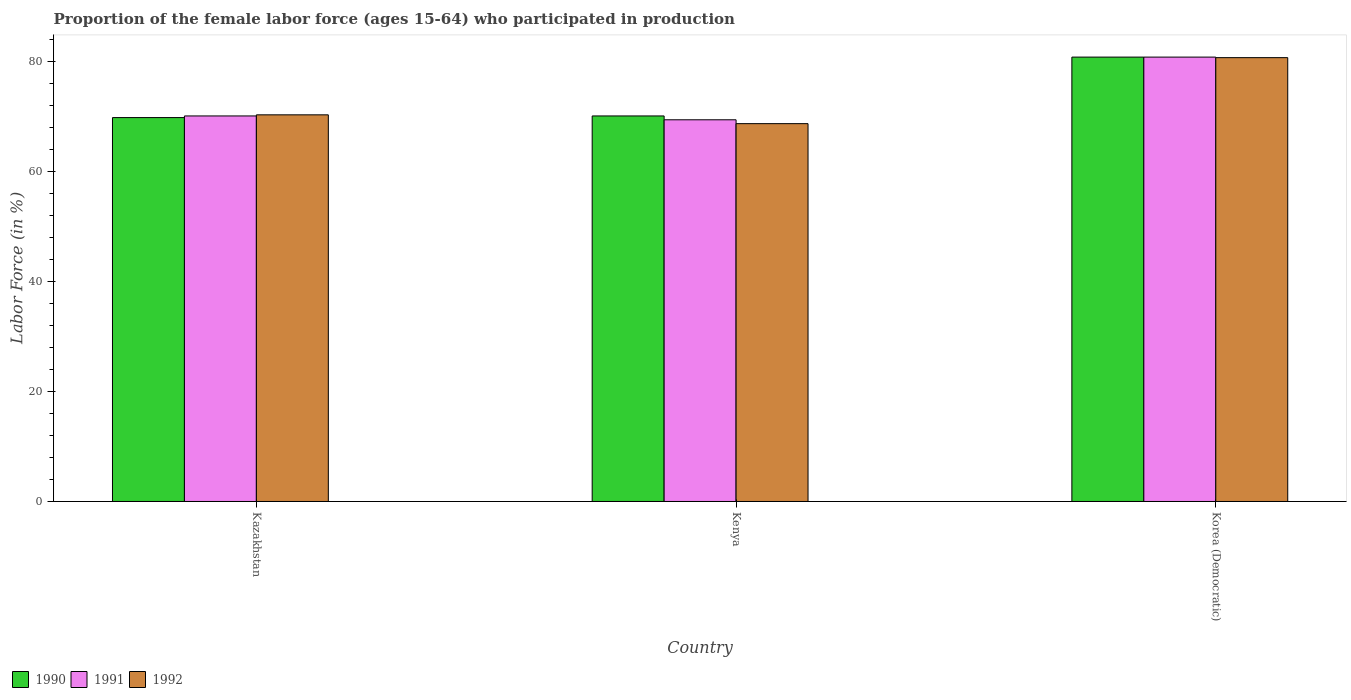Are the number of bars on each tick of the X-axis equal?
Your answer should be compact. Yes. How many bars are there on the 2nd tick from the right?
Your answer should be compact. 3. What is the label of the 3rd group of bars from the left?
Give a very brief answer. Korea (Democratic). In how many cases, is the number of bars for a given country not equal to the number of legend labels?
Ensure brevity in your answer.  0. What is the proportion of the female labor force who participated in production in 1991 in Kenya?
Offer a terse response. 69.4. Across all countries, what is the maximum proportion of the female labor force who participated in production in 1991?
Offer a terse response. 80.8. Across all countries, what is the minimum proportion of the female labor force who participated in production in 1990?
Your answer should be compact. 69.8. In which country was the proportion of the female labor force who participated in production in 1992 maximum?
Your answer should be very brief. Korea (Democratic). In which country was the proportion of the female labor force who participated in production in 1990 minimum?
Make the answer very short. Kazakhstan. What is the total proportion of the female labor force who participated in production in 1991 in the graph?
Your answer should be very brief. 220.3. What is the difference between the proportion of the female labor force who participated in production in 1991 in Kazakhstan and that in Korea (Democratic)?
Keep it short and to the point. -10.7. What is the difference between the proportion of the female labor force who participated in production in 1992 in Korea (Democratic) and the proportion of the female labor force who participated in production in 1990 in Kazakhstan?
Make the answer very short. 10.9. What is the average proportion of the female labor force who participated in production in 1990 per country?
Provide a succinct answer. 73.57. What is the difference between the proportion of the female labor force who participated in production of/in 1992 and proportion of the female labor force who participated in production of/in 1991 in Korea (Democratic)?
Your response must be concise. -0.1. What is the ratio of the proportion of the female labor force who participated in production in 1991 in Kazakhstan to that in Korea (Democratic)?
Provide a short and direct response. 0.87. What is the difference between the highest and the second highest proportion of the female labor force who participated in production in 1991?
Give a very brief answer. 11.4. In how many countries, is the proportion of the female labor force who participated in production in 1990 greater than the average proportion of the female labor force who participated in production in 1990 taken over all countries?
Your answer should be compact. 1. What does the 2nd bar from the right in Korea (Democratic) represents?
Your response must be concise. 1991. Is it the case that in every country, the sum of the proportion of the female labor force who participated in production in 1992 and proportion of the female labor force who participated in production in 1990 is greater than the proportion of the female labor force who participated in production in 1991?
Offer a very short reply. Yes. Are all the bars in the graph horizontal?
Ensure brevity in your answer.  No. How many legend labels are there?
Give a very brief answer. 3. How are the legend labels stacked?
Ensure brevity in your answer.  Horizontal. What is the title of the graph?
Your answer should be very brief. Proportion of the female labor force (ages 15-64) who participated in production. Does "1968" appear as one of the legend labels in the graph?
Offer a very short reply. No. What is the Labor Force (in %) in 1990 in Kazakhstan?
Provide a succinct answer. 69.8. What is the Labor Force (in %) of 1991 in Kazakhstan?
Your answer should be compact. 70.1. What is the Labor Force (in %) in 1992 in Kazakhstan?
Your response must be concise. 70.3. What is the Labor Force (in %) in 1990 in Kenya?
Provide a succinct answer. 70.1. What is the Labor Force (in %) of 1991 in Kenya?
Your answer should be compact. 69.4. What is the Labor Force (in %) of 1992 in Kenya?
Provide a succinct answer. 68.7. What is the Labor Force (in %) in 1990 in Korea (Democratic)?
Offer a very short reply. 80.8. What is the Labor Force (in %) of 1991 in Korea (Democratic)?
Your response must be concise. 80.8. What is the Labor Force (in %) of 1992 in Korea (Democratic)?
Ensure brevity in your answer.  80.7. Across all countries, what is the maximum Labor Force (in %) in 1990?
Give a very brief answer. 80.8. Across all countries, what is the maximum Labor Force (in %) of 1991?
Your response must be concise. 80.8. Across all countries, what is the maximum Labor Force (in %) in 1992?
Keep it short and to the point. 80.7. Across all countries, what is the minimum Labor Force (in %) in 1990?
Give a very brief answer. 69.8. Across all countries, what is the minimum Labor Force (in %) of 1991?
Your answer should be very brief. 69.4. Across all countries, what is the minimum Labor Force (in %) in 1992?
Your answer should be very brief. 68.7. What is the total Labor Force (in %) in 1990 in the graph?
Ensure brevity in your answer.  220.7. What is the total Labor Force (in %) in 1991 in the graph?
Provide a succinct answer. 220.3. What is the total Labor Force (in %) of 1992 in the graph?
Provide a short and direct response. 219.7. What is the difference between the Labor Force (in %) of 1991 in Kazakhstan and that in Kenya?
Ensure brevity in your answer.  0.7. What is the difference between the Labor Force (in %) in 1991 in Kazakhstan and that in Korea (Democratic)?
Make the answer very short. -10.7. What is the difference between the Labor Force (in %) of 1992 in Kazakhstan and that in Korea (Democratic)?
Make the answer very short. -10.4. What is the difference between the Labor Force (in %) in 1992 in Kenya and that in Korea (Democratic)?
Provide a short and direct response. -12. What is the difference between the Labor Force (in %) of 1990 in Kazakhstan and the Labor Force (in %) of 1991 in Kenya?
Your answer should be very brief. 0.4. What is the difference between the Labor Force (in %) in 1990 in Kazakhstan and the Labor Force (in %) in 1992 in Kenya?
Keep it short and to the point. 1.1. What is the difference between the Labor Force (in %) in 1991 in Kazakhstan and the Labor Force (in %) in 1992 in Kenya?
Make the answer very short. 1.4. What is the difference between the Labor Force (in %) of 1990 in Kazakhstan and the Labor Force (in %) of 1992 in Korea (Democratic)?
Provide a succinct answer. -10.9. What is the difference between the Labor Force (in %) of 1991 in Kazakhstan and the Labor Force (in %) of 1992 in Korea (Democratic)?
Give a very brief answer. -10.6. What is the difference between the Labor Force (in %) of 1990 in Kenya and the Labor Force (in %) of 1991 in Korea (Democratic)?
Offer a very short reply. -10.7. What is the difference between the Labor Force (in %) of 1990 in Kenya and the Labor Force (in %) of 1992 in Korea (Democratic)?
Offer a terse response. -10.6. What is the difference between the Labor Force (in %) in 1991 in Kenya and the Labor Force (in %) in 1992 in Korea (Democratic)?
Provide a short and direct response. -11.3. What is the average Labor Force (in %) of 1990 per country?
Provide a succinct answer. 73.57. What is the average Labor Force (in %) in 1991 per country?
Provide a short and direct response. 73.43. What is the average Labor Force (in %) in 1992 per country?
Ensure brevity in your answer.  73.23. What is the difference between the Labor Force (in %) in 1990 and Labor Force (in %) in 1991 in Kazakhstan?
Offer a very short reply. -0.3. What is the difference between the Labor Force (in %) in 1990 and Labor Force (in %) in 1991 in Kenya?
Offer a terse response. 0.7. What is the difference between the Labor Force (in %) in 1990 and Labor Force (in %) in 1991 in Korea (Democratic)?
Provide a succinct answer. 0. What is the difference between the Labor Force (in %) in 1991 and Labor Force (in %) in 1992 in Korea (Democratic)?
Your answer should be very brief. 0.1. What is the ratio of the Labor Force (in %) of 1990 in Kazakhstan to that in Kenya?
Offer a terse response. 1. What is the ratio of the Labor Force (in %) in 1991 in Kazakhstan to that in Kenya?
Give a very brief answer. 1.01. What is the ratio of the Labor Force (in %) of 1992 in Kazakhstan to that in Kenya?
Your answer should be very brief. 1.02. What is the ratio of the Labor Force (in %) of 1990 in Kazakhstan to that in Korea (Democratic)?
Provide a succinct answer. 0.86. What is the ratio of the Labor Force (in %) in 1991 in Kazakhstan to that in Korea (Democratic)?
Keep it short and to the point. 0.87. What is the ratio of the Labor Force (in %) in 1992 in Kazakhstan to that in Korea (Democratic)?
Keep it short and to the point. 0.87. What is the ratio of the Labor Force (in %) of 1990 in Kenya to that in Korea (Democratic)?
Your response must be concise. 0.87. What is the ratio of the Labor Force (in %) of 1991 in Kenya to that in Korea (Democratic)?
Your response must be concise. 0.86. What is the ratio of the Labor Force (in %) in 1992 in Kenya to that in Korea (Democratic)?
Make the answer very short. 0.85. What is the difference between the highest and the second highest Labor Force (in %) in 1990?
Keep it short and to the point. 10.7. What is the difference between the highest and the second highest Labor Force (in %) in 1992?
Make the answer very short. 10.4. What is the difference between the highest and the lowest Labor Force (in %) in 1991?
Your answer should be very brief. 11.4. What is the difference between the highest and the lowest Labor Force (in %) of 1992?
Give a very brief answer. 12. 